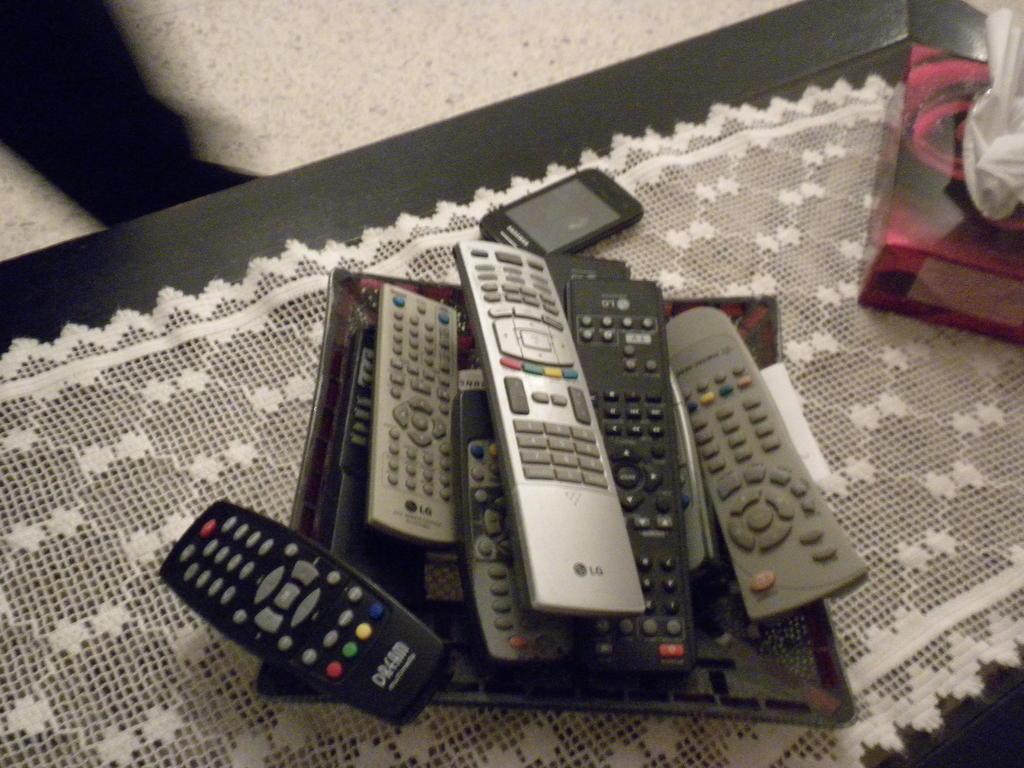Could you give a brief overview of what you see in this image? This image is taken indoors. At the top of the image there is a floor and there is a person's leg. At the bottom of the image there is a table with a tablecloth, a mobile phone, a tissue paper box and a tray with many remotes on it. 